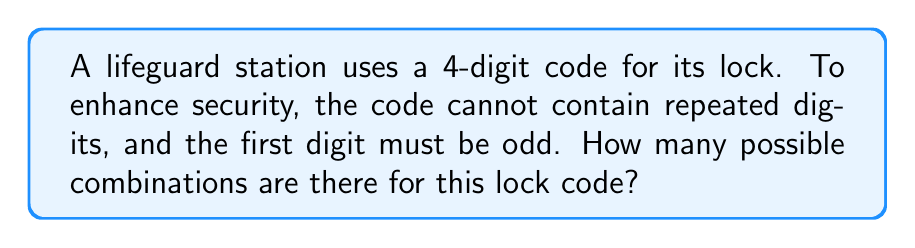Can you solve this math problem? Let's approach this step-by-step:

1) First, we need to determine how many choices we have for the first digit:
   - It must be odd, so our choices are 1, 3, 5, 7, 9
   - Thus, we have 5 choices for the first digit

2) For the second digit:
   - We can't use the digit we used for the first position
   - We have 9 choices left (0-9, excluding the one used)

3) For the third digit:
   - We can't use the digits used in the first two positions
   - We have 8 choices left

4) For the fourth and final digit:
   - We can't use the digits used in the first three positions
   - We have 7 choices left

5) Now, we can apply the multiplication principle of counting:
   $$ \text{Total combinations} = 5 \times 9 \times 8 \times 7 $$

6) Let's calculate:
   $$ 5 \times 9 \times 8 \times 7 = 2,520 $$

Therefore, there are 2,520 possible combinations for the lifeguard station's lock code.
Answer: 2,520 